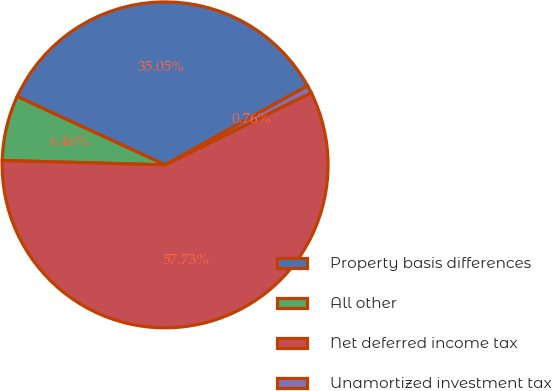<chart> <loc_0><loc_0><loc_500><loc_500><pie_chart><fcel>Property basis differences<fcel>All other<fcel>Net deferred income tax<fcel>Unamortized investment tax<nl><fcel>35.05%<fcel>6.46%<fcel>57.73%<fcel>0.76%<nl></chart> 